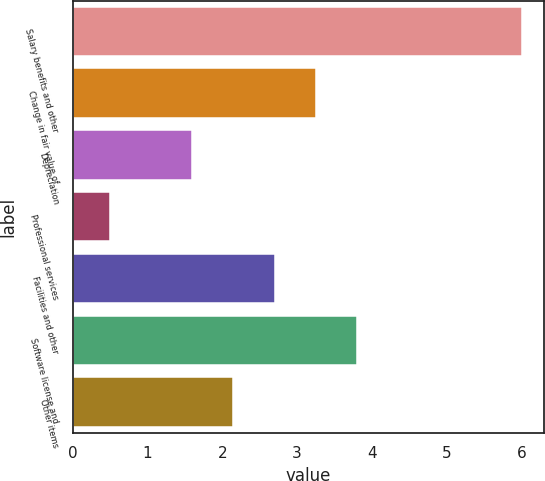<chart> <loc_0><loc_0><loc_500><loc_500><bar_chart><fcel>Salary benefits and other<fcel>Change in fair value of<fcel>Depreciation<fcel>Professional services<fcel>Facilities and other<fcel>Software license and<fcel>Other items<nl><fcel>6<fcel>3.25<fcel>1.6<fcel>0.5<fcel>2.7<fcel>3.8<fcel>2.15<nl></chart> 